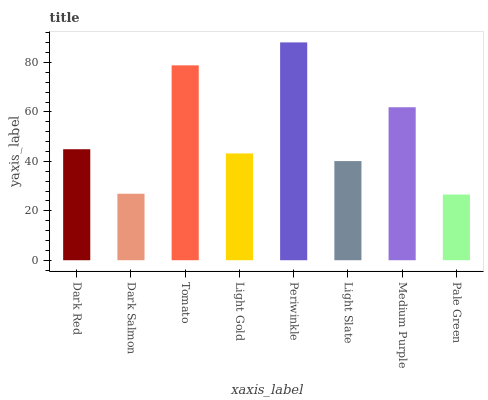Is Pale Green the minimum?
Answer yes or no. Yes. Is Periwinkle the maximum?
Answer yes or no. Yes. Is Dark Salmon the minimum?
Answer yes or no. No. Is Dark Salmon the maximum?
Answer yes or no. No. Is Dark Red greater than Dark Salmon?
Answer yes or no. Yes. Is Dark Salmon less than Dark Red?
Answer yes or no. Yes. Is Dark Salmon greater than Dark Red?
Answer yes or no. No. Is Dark Red less than Dark Salmon?
Answer yes or no. No. Is Dark Red the high median?
Answer yes or no. Yes. Is Light Gold the low median?
Answer yes or no. Yes. Is Medium Purple the high median?
Answer yes or no. No. Is Pale Green the low median?
Answer yes or no. No. 